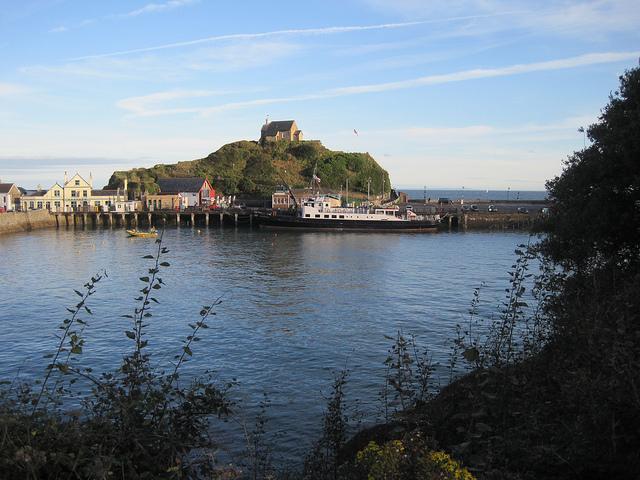Is there a body of water?
Be succinct. Yes. Is the water yellow?
Answer briefly. No. What is on the top of the hill?
Be succinct. House. Are there any people at the dock?
Concise answer only. No. How many buildings are there?
Give a very brief answer. 6. 